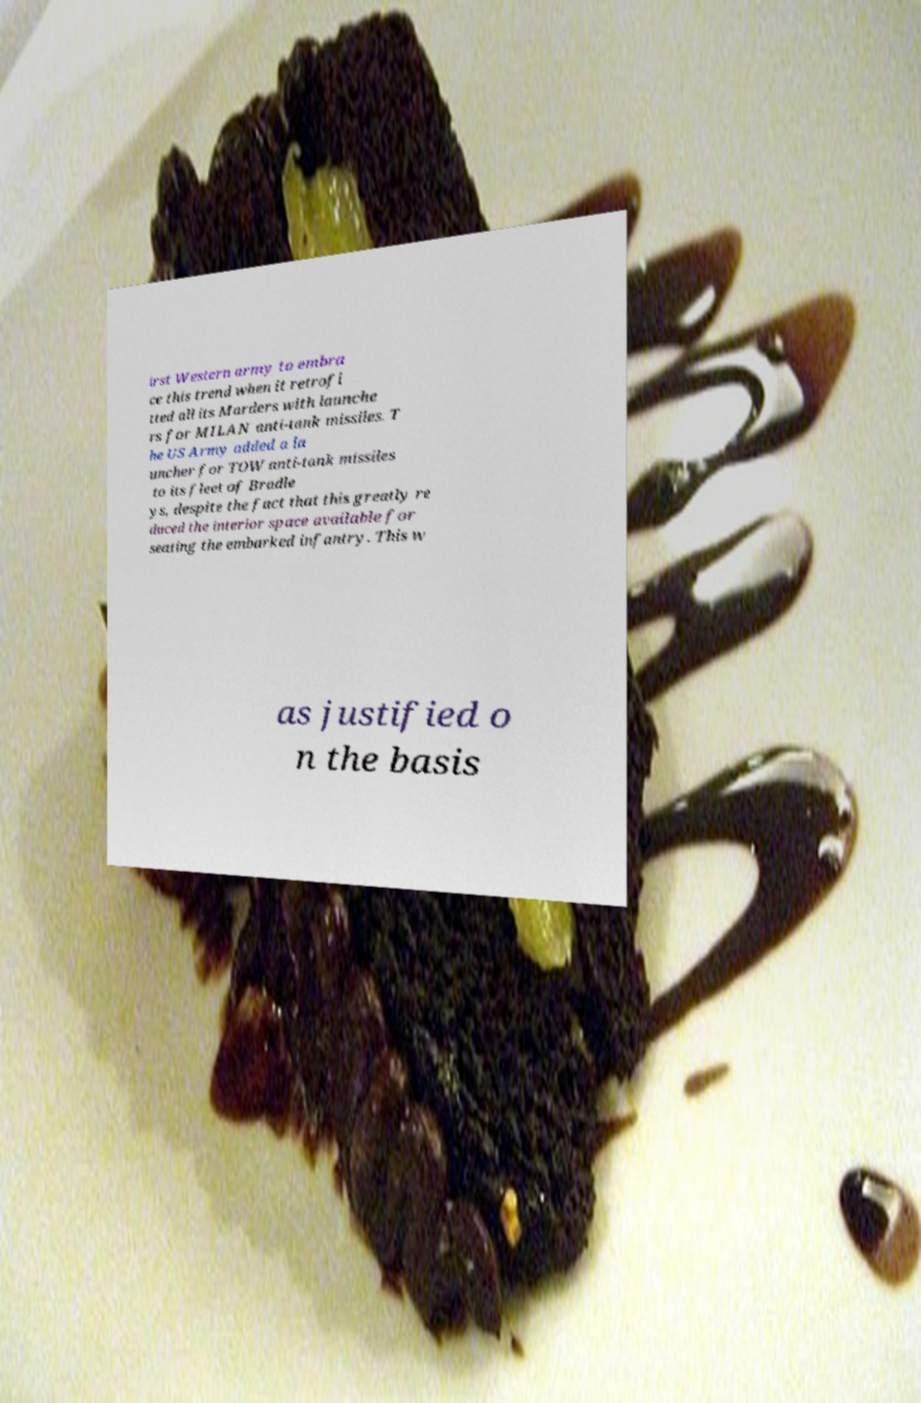What messages or text are displayed in this image? I need them in a readable, typed format. irst Western army to embra ce this trend when it retrofi tted all its Marders with launche rs for MILAN anti-tank missiles. T he US Army added a la uncher for TOW anti-tank missiles to its fleet of Bradle ys, despite the fact that this greatly re duced the interior space available for seating the embarked infantry. This w as justified o n the basis 